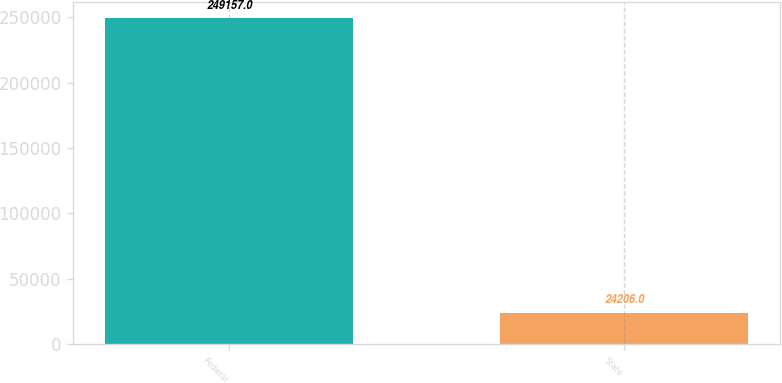Convert chart. <chart><loc_0><loc_0><loc_500><loc_500><bar_chart><fcel>Federal<fcel>State<nl><fcel>249157<fcel>24206<nl></chart> 